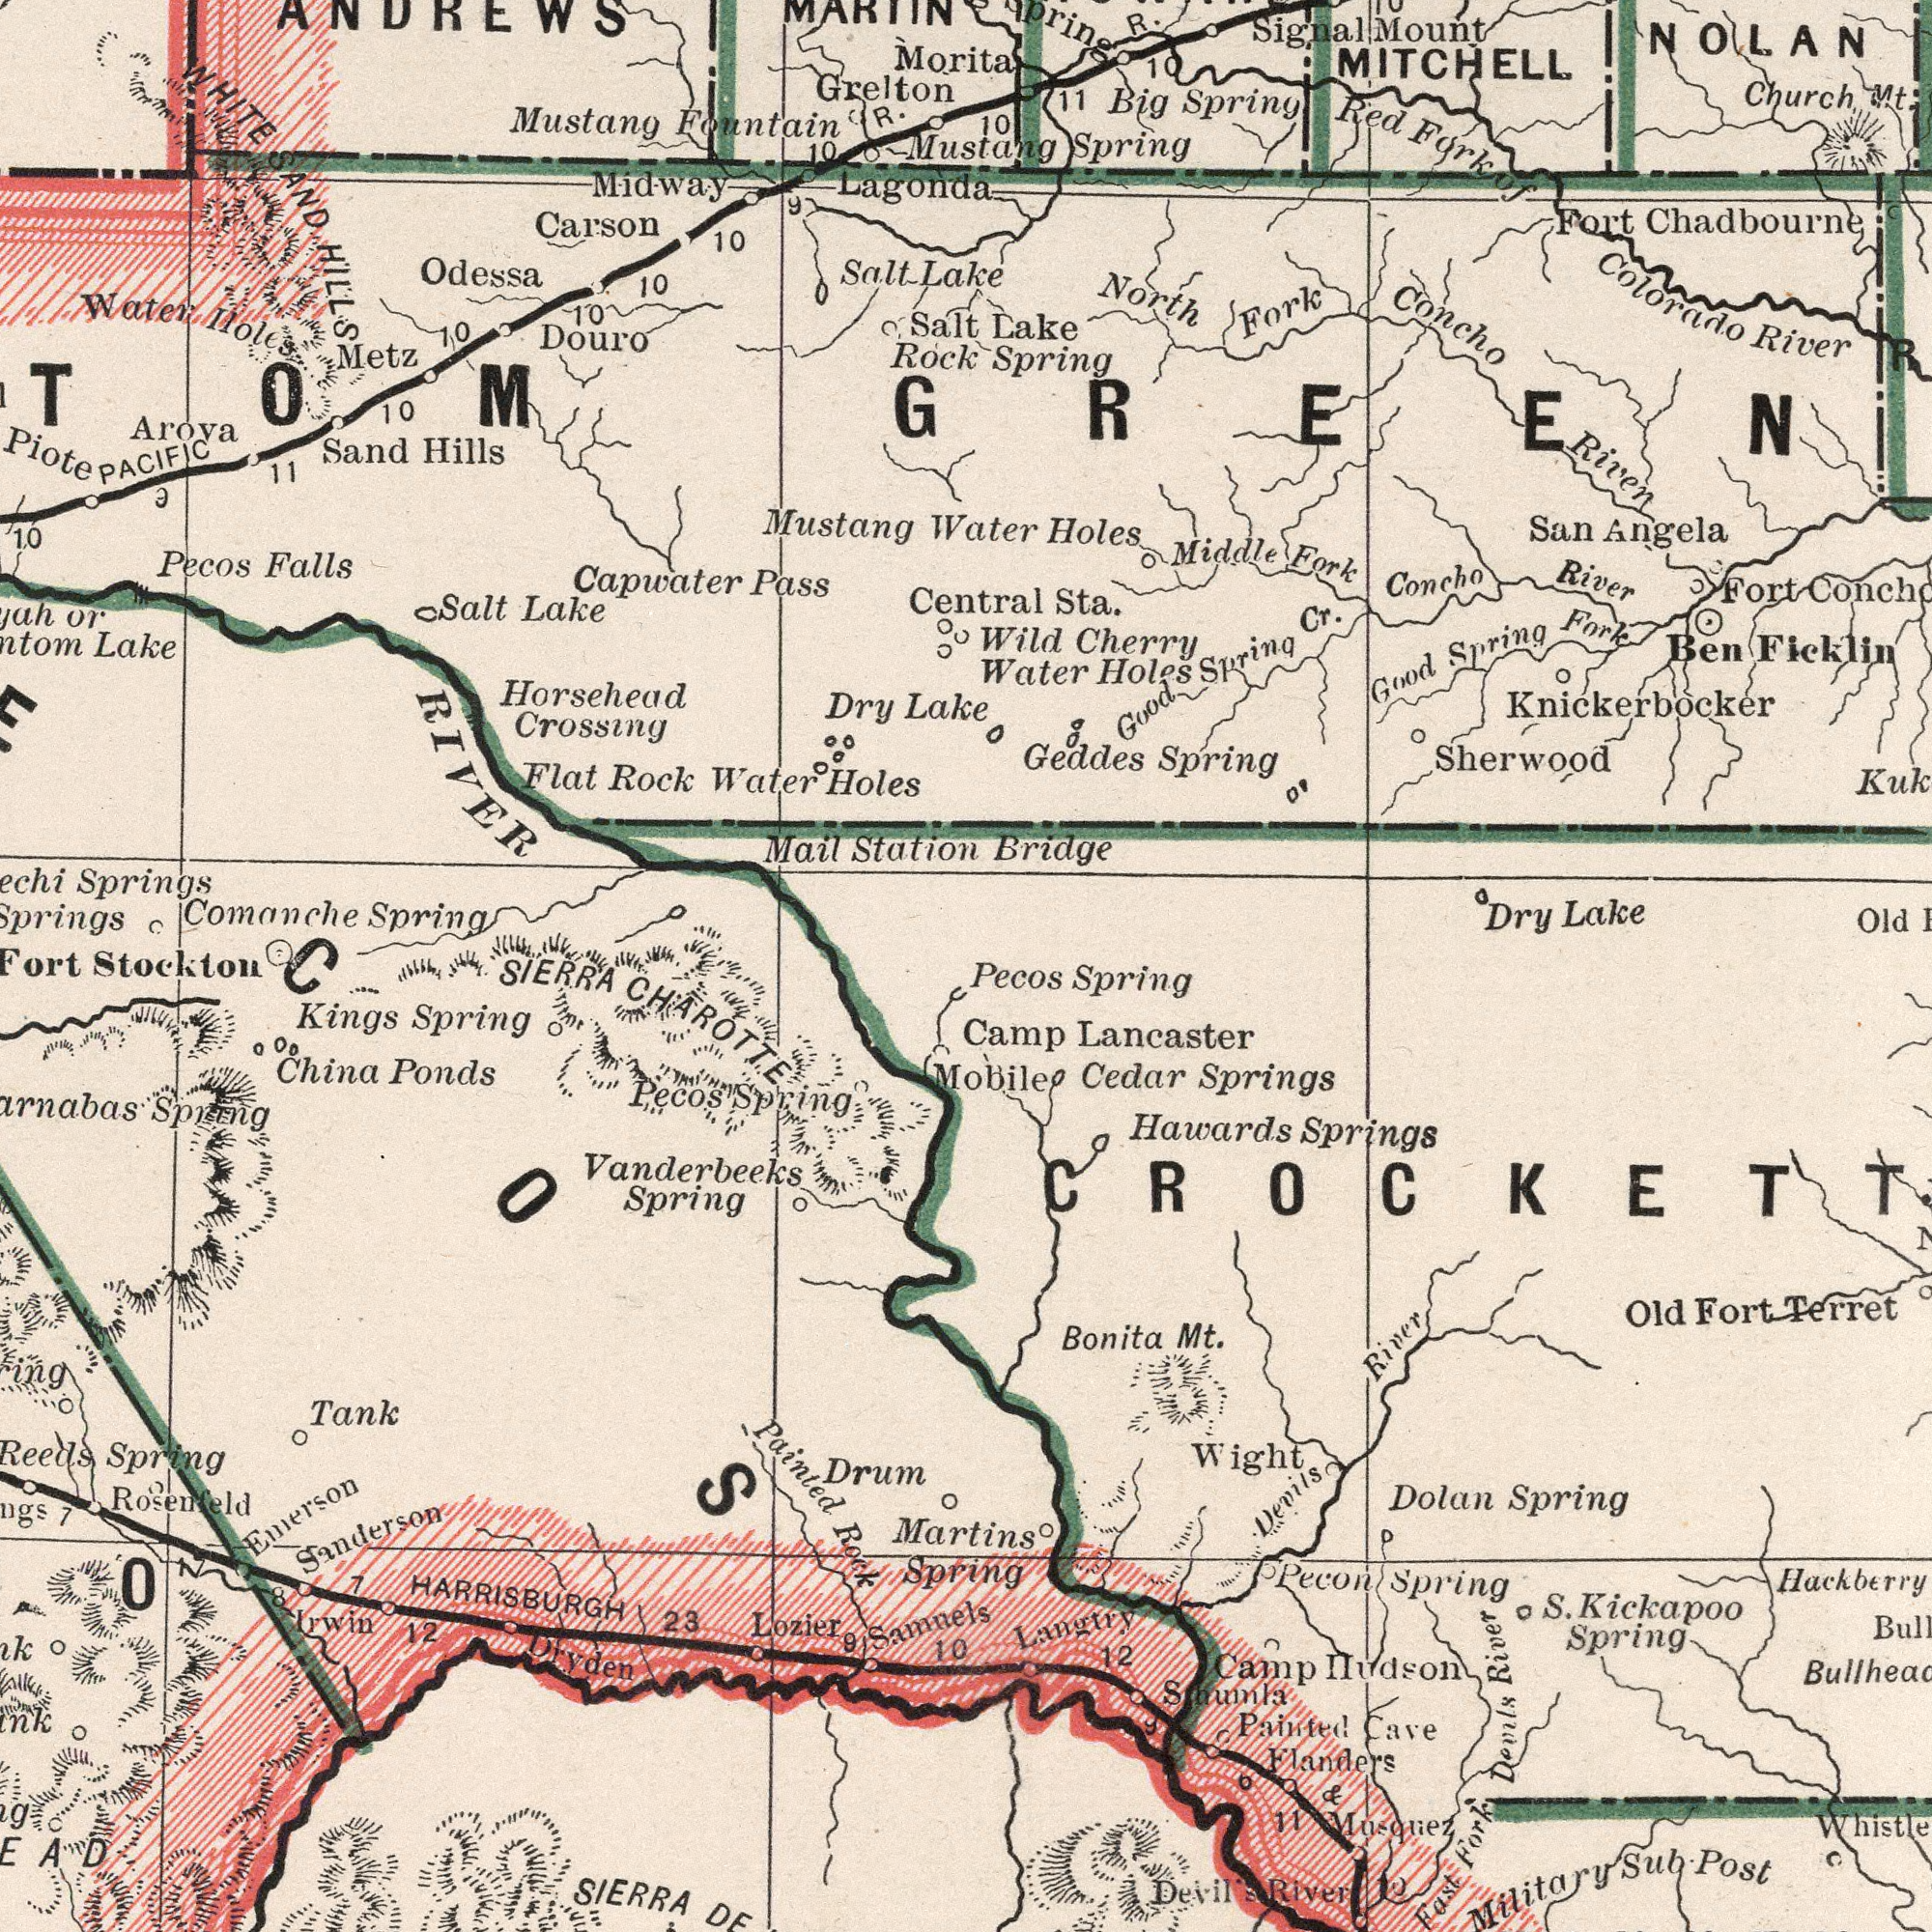What text is visible in the lower-left corner? Sanderson Emerson SIERRA Painted Rock Drum Spirng Vanderbeeks Spring China Ponds Kings Spring 12 Spring Lozier Tank SIERRA CHAROTTE Rosenfeld 23 Dryden HARRISBURGH Pecos Spring Irwin Samnels 7 O 7 10 9 8 What text is shown in the top-right quadrant? Water Holes Bridge Spring Mustang Spring R. Lake Central Sta. Red Fork of Geddes Spring Church Mt. MITCHELL NOLAN Fort Chadbourne Colorado River Middle Fork Big Spring Ben Ficklin San Angela North Fork Concho River Dry Lake Wild Cherry Concho River Water Holes Old P## Good Spring Fork Sherwood Fort 11 10 Good Spring Cr. Spring Signal Mount R 10 Knickerbocker GREEN What text is visible in the lower-right corner? Martins Spring Mobile Hawards Springs Pecos Spring Cedar Springs Old Fort Terret Flanders & Musquez S. Kickapoo Spring Camp Hudson Langtry Dolan Spring Pecon Spring Devils River Devils River Bonita Mt. Wight Fast Fork Devils River Whistle Smumla Camp Lancaster Military Sub. Post 12 Painted Cave 11 10 8 What text is visible in the upper-left corner? Comanche Spring or Lake Mustang Springs Mustang Fountain Capwater Pass Midway Douro Metz Horsehead Crossing Flat Rock Water Holes Pecos Falls Grelton Sand Hills Mail Station Carson 10 Rock Odessa Salt Lake 10 10 Dry Lake Salt Lake WHITE SAND HILLS Morita PACIFIC R. 1.0 11 Salt ANDREWS Lagonda 10 Water Holes 9 10 Arova 10 Piote Stockton 9 TOM 